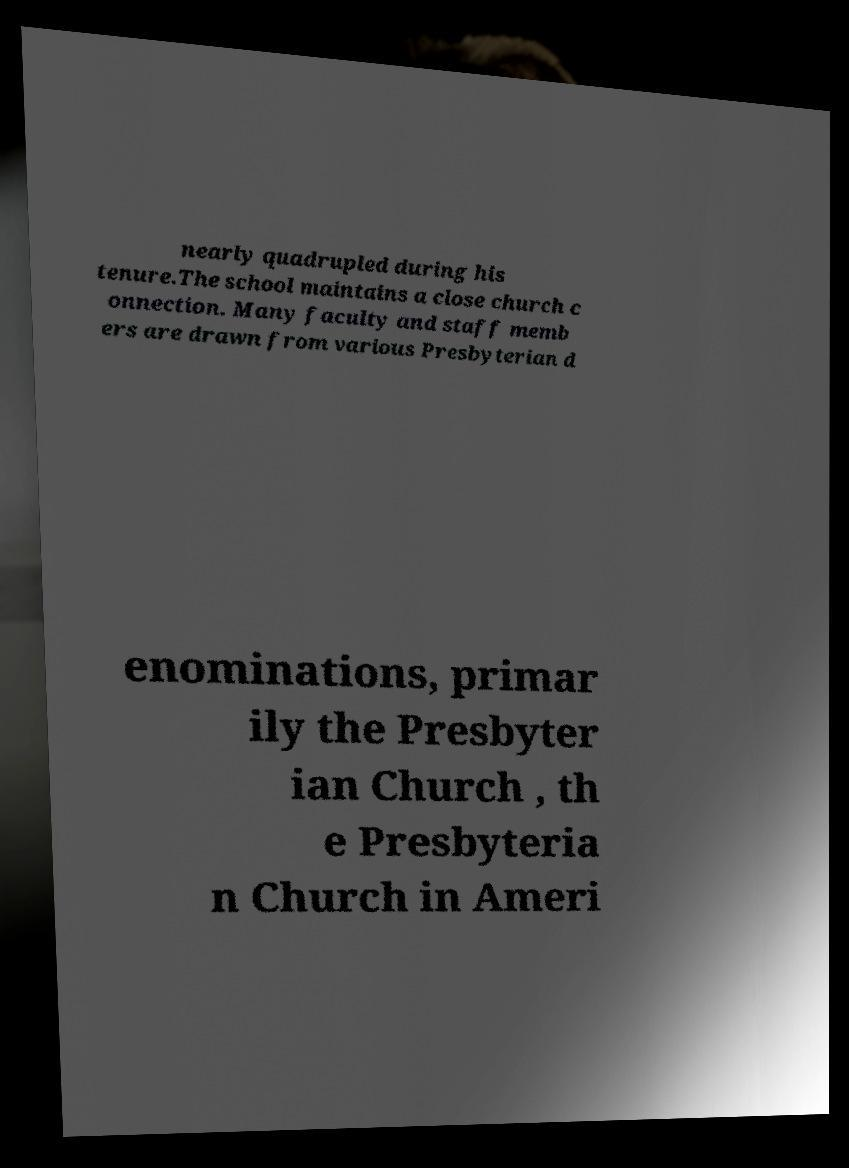Please identify and transcribe the text found in this image. nearly quadrupled during his tenure.The school maintains a close church c onnection. Many faculty and staff memb ers are drawn from various Presbyterian d enominations, primar ily the Presbyter ian Church , th e Presbyteria n Church in Ameri 